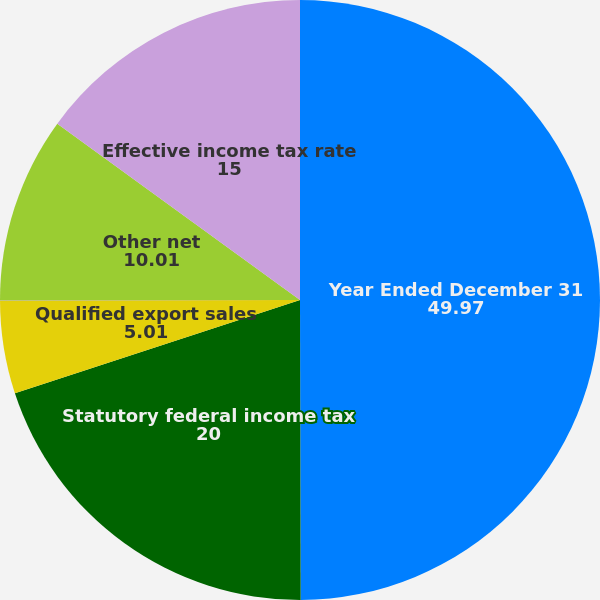Convert chart to OTSL. <chart><loc_0><loc_0><loc_500><loc_500><pie_chart><fcel>Year Ended December 31<fcel>Statutory federal income tax<fcel>Qualified export sales<fcel>Tax credits<fcel>Other net<fcel>Effective income tax rate<nl><fcel>49.97%<fcel>20.0%<fcel>5.01%<fcel>0.02%<fcel>10.01%<fcel>15.0%<nl></chart> 